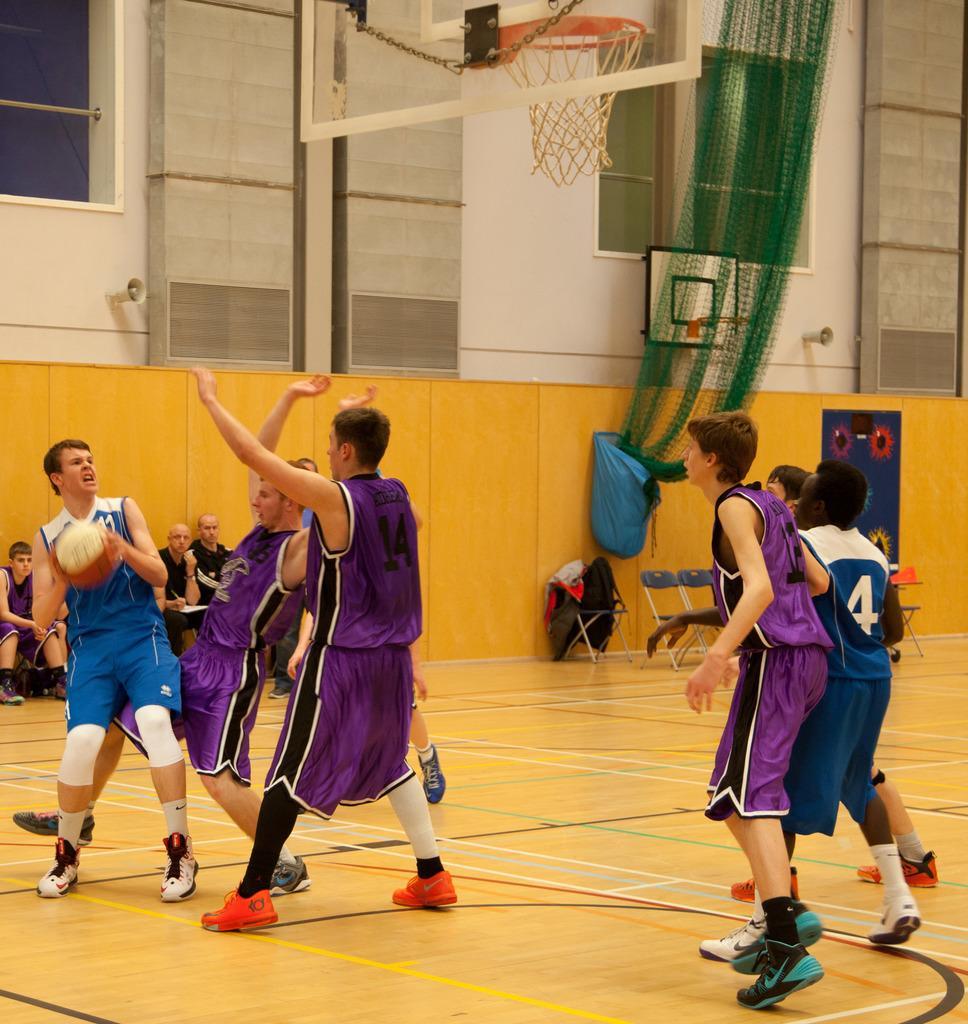Please provide a concise description of this image. In the image we can see there are many people wearing clothes, shoes and socks, and these people are wearing basketball. This is a basketball and a basketball court. This is a net, chain, window and other objects. There are even people sitting on chairs. 